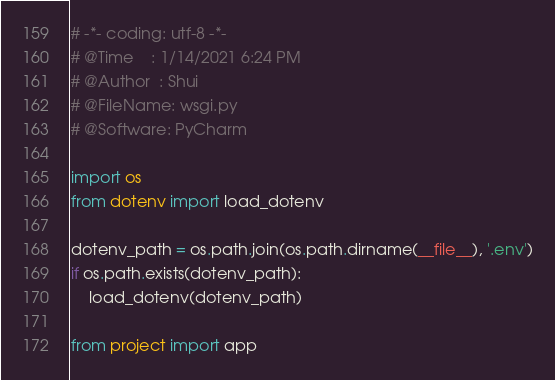Convert code to text. <code><loc_0><loc_0><loc_500><loc_500><_Python_># -*- coding: utf-8 -*-
# @Time    : 1/14/2021 6:24 PM
# @Author  : Shui
# @FileName: wsgi.py
# @Software: PyCharm

import os
from dotenv import load_dotenv

dotenv_path = os.path.join(os.path.dirname(__file__), '.env')
if os.path.exists(dotenv_path):
    load_dotenv(dotenv_path)

from project import app</code> 